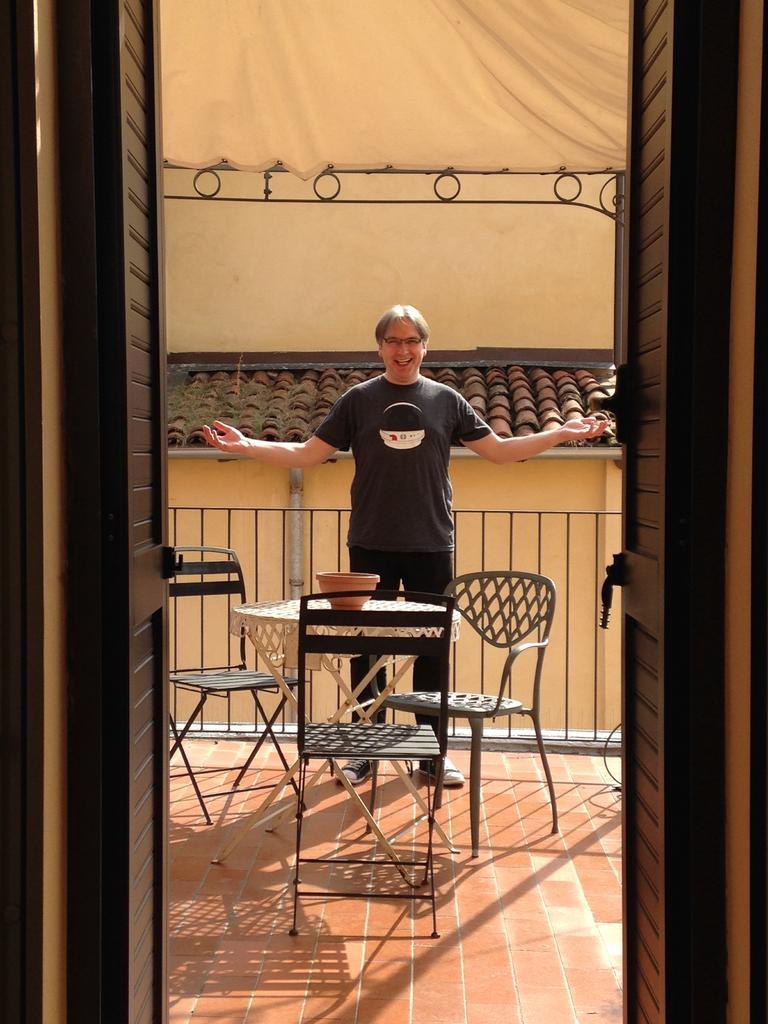How would you summarize this image in a sentence or two? In this picture a man is standing, in front of him we can see a bowl on the table and couple of chairs. 